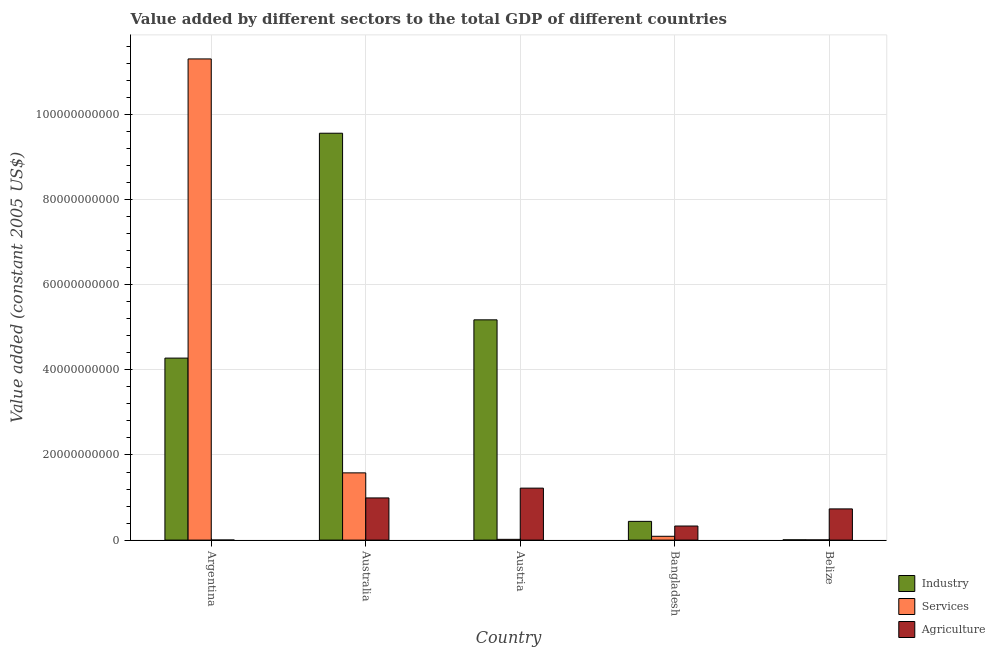How many different coloured bars are there?
Your response must be concise. 3. Are the number of bars per tick equal to the number of legend labels?
Offer a terse response. Yes. Are the number of bars on each tick of the X-axis equal?
Your answer should be compact. Yes. What is the value added by services in Austria?
Your response must be concise. 1.81e+08. Across all countries, what is the maximum value added by services?
Offer a very short reply. 1.13e+11. Across all countries, what is the minimum value added by industrial sector?
Offer a very short reply. 6.39e+07. In which country was the value added by services maximum?
Keep it short and to the point. Argentina. In which country was the value added by services minimum?
Give a very brief answer. Belize. What is the total value added by agricultural sector in the graph?
Ensure brevity in your answer.  3.28e+1. What is the difference between the value added by agricultural sector in Argentina and that in Austria?
Your answer should be compact. -1.22e+1. What is the difference between the value added by agricultural sector in Belize and the value added by industrial sector in Austria?
Your answer should be very brief. -4.44e+1. What is the average value added by services per country?
Keep it short and to the point. 2.60e+1. What is the difference between the value added by industrial sector and value added by services in Argentina?
Your answer should be very brief. -7.03e+1. What is the ratio of the value added by services in Austria to that in Bangladesh?
Ensure brevity in your answer.  0.2. Is the value added by agricultural sector in Argentina less than that in Bangladesh?
Your response must be concise. Yes. What is the difference between the highest and the second highest value added by industrial sector?
Offer a very short reply. 4.39e+1. What is the difference between the highest and the lowest value added by services?
Provide a succinct answer. 1.13e+11. Is the sum of the value added by industrial sector in Australia and Belize greater than the maximum value added by agricultural sector across all countries?
Provide a succinct answer. Yes. What does the 1st bar from the left in Argentina represents?
Offer a terse response. Industry. What does the 3rd bar from the right in Argentina represents?
Your response must be concise. Industry. Are all the bars in the graph horizontal?
Offer a terse response. No. What is the difference between two consecutive major ticks on the Y-axis?
Provide a succinct answer. 2.00e+1. Are the values on the major ticks of Y-axis written in scientific E-notation?
Keep it short and to the point. No. Does the graph contain any zero values?
Ensure brevity in your answer.  No. Does the graph contain grids?
Keep it short and to the point. Yes. How are the legend labels stacked?
Your answer should be compact. Vertical. What is the title of the graph?
Your answer should be compact. Value added by different sectors to the total GDP of different countries. What is the label or title of the X-axis?
Your answer should be compact. Country. What is the label or title of the Y-axis?
Your response must be concise. Value added (constant 2005 US$). What is the Value added (constant 2005 US$) in Industry in Argentina?
Ensure brevity in your answer.  4.28e+1. What is the Value added (constant 2005 US$) of Services in Argentina?
Provide a succinct answer. 1.13e+11. What is the Value added (constant 2005 US$) in Agriculture in Argentina?
Offer a terse response. 1.01e+07. What is the Value added (constant 2005 US$) of Industry in Australia?
Your response must be concise. 9.56e+1. What is the Value added (constant 2005 US$) in Services in Australia?
Your answer should be compact. 1.58e+1. What is the Value added (constant 2005 US$) in Agriculture in Australia?
Offer a terse response. 9.91e+09. What is the Value added (constant 2005 US$) in Industry in Austria?
Give a very brief answer. 5.18e+1. What is the Value added (constant 2005 US$) of Services in Austria?
Keep it short and to the point. 1.81e+08. What is the Value added (constant 2005 US$) of Agriculture in Austria?
Ensure brevity in your answer.  1.22e+1. What is the Value added (constant 2005 US$) in Industry in Bangladesh?
Your answer should be compact. 4.40e+09. What is the Value added (constant 2005 US$) in Services in Bangladesh?
Provide a short and direct response. 8.97e+08. What is the Value added (constant 2005 US$) of Agriculture in Bangladesh?
Keep it short and to the point. 3.31e+09. What is the Value added (constant 2005 US$) in Industry in Belize?
Ensure brevity in your answer.  6.39e+07. What is the Value added (constant 2005 US$) of Services in Belize?
Offer a very short reply. 4.88e+07. What is the Value added (constant 2005 US$) of Agriculture in Belize?
Keep it short and to the point. 7.33e+09. Across all countries, what is the maximum Value added (constant 2005 US$) of Industry?
Provide a short and direct response. 9.56e+1. Across all countries, what is the maximum Value added (constant 2005 US$) in Services?
Make the answer very short. 1.13e+11. Across all countries, what is the maximum Value added (constant 2005 US$) of Agriculture?
Your answer should be very brief. 1.22e+1. Across all countries, what is the minimum Value added (constant 2005 US$) in Industry?
Your answer should be compact. 6.39e+07. Across all countries, what is the minimum Value added (constant 2005 US$) in Services?
Make the answer very short. 4.88e+07. Across all countries, what is the minimum Value added (constant 2005 US$) of Agriculture?
Your answer should be very brief. 1.01e+07. What is the total Value added (constant 2005 US$) in Industry in the graph?
Your response must be concise. 1.95e+11. What is the total Value added (constant 2005 US$) in Services in the graph?
Provide a succinct answer. 1.30e+11. What is the total Value added (constant 2005 US$) in Agriculture in the graph?
Your answer should be compact. 3.28e+1. What is the difference between the Value added (constant 2005 US$) in Industry in Argentina and that in Australia?
Provide a succinct answer. -5.28e+1. What is the difference between the Value added (constant 2005 US$) in Services in Argentina and that in Australia?
Keep it short and to the point. 9.73e+1. What is the difference between the Value added (constant 2005 US$) in Agriculture in Argentina and that in Australia?
Make the answer very short. -9.90e+09. What is the difference between the Value added (constant 2005 US$) in Industry in Argentina and that in Austria?
Make the answer very short. -8.99e+09. What is the difference between the Value added (constant 2005 US$) of Services in Argentina and that in Austria?
Offer a very short reply. 1.13e+11. What is the difference between the Value added (constant 2005 US$) in Agriculture in Argentina and that in Austria?
Your answer should be compact. -1.22e+1. What is the difference between the Value added (constant 2005 US$) of Industry in Argentina and that in Bangladesh?
Offer a very short reply. 3.84e+1. What is the difference between the Value added (constant 2005 US$) of Services in Argentina and that in Bangladesh?
Ensure brevity in your answer.  1.12e+11. What is the difference between the Value added (constant 2005 US$) in Agriculture in Argentina and that in Bangladesh?
Provide a short and direct response. -3.30e+09. What is the difference between the Value added (constant 2005 US$) in Industry in Argentina and that in Belize?
Your answer should be very brief. 4.27e+1. What is the difference between the Value added (constant 2005 US$) of Services in Argentina and that in Belize?
Keep it short and to the point. 1.13e+11. What is the difference between the Value added (constant 2005 US$) of Agriculture in Argentina and that in Belize?
Ensure brevity in your answer.  -7.32e+09. What is the difference between the Value added (constant 2005 US$) in Industry in Australia and that in Austria?
Provide a short and direct response. 4.39e+1. What is the difference between the Value added (constant 2005 US$) of Services in Australia and that in Austria?
Ensure brevity in your answer.  1.56e+1. What is the difference between the Value added (constant 2005 US$) in Agriculture in Australia and that in Austria?
Your answer should be compact. -2.30e+09. What is the difference between the Value added (constant 2005 US$) of Industry in Australia and that in Bangladesh?
Provide a short and direct response. 9.12e+1. What is the difference between the Value added (constant 2005 US$) of Services in Australia and that in Bangladesh?
Make the answer very short. 1.49e+1. What is the difference between the Value added (constant 2005 US$) of Agriculture in Australia and that in Bangladesh?
Offer a very short reply. 6.60e+09. What is the difference between the Value added (constant 2005 US$) in Industry in Australia and that in Belize?
Offer a very short reply. 9.55e+1. What is the difference between the Value added (constant 2005 US$) in Services in Australia and that in Belize?
Offer a very short reply. 1.58e+1. What is the difference between the Value added (constant 2005 US$) of Agriculture in Australia and that in Belize?
Your response must be concise. 2.58e+09. What is the difference between the Value added (constant 2005 US$) in Industry in Austria and that in Bangladesh?
Your answer should be compact. 4.74e+1. What is the difference between the Value added (constant 2005 US$) of Services in Austria and that in Bangladesh?
Provide a succinct answer. -7.16e+08. What is the difference between the Value added (constant 2005 US$) in Agriculture in Austria and that in Bangladesh?
Your response must be concise. 8.90e+09. What is the difference between the Value added (constant 2005 US$) of Industry in Austria and that in Belize?
Provide a succinct answer. 5.17e+1. What is the difference between the Value added (constant 2005 US$) of Services in Austria and that in Belize?
Your answer should be compact. 1.32e+08. What is the difference between the Value added (constant 2005 US$) of Agriculture in Austria and that in Belize?
Your response must be concise. 4.88e+09. What is the difference between the Value added (constant 2005 US$) of Industry in Bangladesh and that in Belize?
Your response must be concise. 4.34e+09. What is the difference between the Value added (constant 2005 US$) of Services in Bangladesh and that in Belize?
Make the answer very short. 8.48e+08. What is the difference between the Value added (constant 2005 US$) in Agriculture in Bangladesh and that in Belize?
Provide a succinct answer. -4.02e+09. What is the difference between the Value added (constant 2005 US$) of Industry in Argentina and the Value added (constant 2005 US$) of Services in Australia?
Keep it short and to the point. 2.70e+1. What is the difference between the Value added (constant 2005 US$) of Industry in Argentina and the Value added (constant 2005 US$) of Agriculture in Australia?
Ensure brevity in your answer.  3.29e+1. What is the difference between the Value added (constant 2005 US$) in Services in Argentina and the Value added (constant 2005 US$) in Agriculture in Australia?
Make the answer very short. 1.03e+11. What is the difference between the Value added (constant 2005 US$) in Industry in Argentina and the Value added (constant 2005 US$) in Services in Austria?
Offer a terse response. 4.26e+1. What is the difference between the Value added (constant 2005 US$) of Industry in Argentina and the Value added (constant 2005 US$) of Agriculture in Austria?
Give a very brief answer. 3.06e+1. What is the difference between the Value added (constant 2005 US$) in Services in Argentina and the Value added (constant 2005 US$) in Agriculture in Austria?
Your answer should be very brief. 1.01e+11. What is the difference between the Value added (constant 2005 US$) in Industry in Argentina and the Value added (constant 2005 US$) in Services in Bangladesh?
Provide a succinct answer. 4.19e+1. What is the difference between the Value added (constant 2005 US$) in Industry in Argentina and the Value added (constant 2005 US$) in Agriculture in Bangladesh?
Offer a very short reply. 3.95e+1. What is the difference between the Value added (constant 2005 US$) in Services in Argentina and the Value added (constant 2005 US$) in Agriculture in Bangladesh?
Offer a very short reply. 1.10e+11. What is the difference between the Value added (constant 2005 US$) of Industry in Argentina and the Value added (constant 2005 US$) of Services in Belize?
Provide a short and direct response. 4.27e+1. What is the difference between the Value added (constant 2005 US$) of Industry in Argentina and the Value added (constant 2005 US$) of Agriculture in Belize?
Your response must be concise. 3.54e+1. What is the difference between the Value added (constant 2005 US$) of Services in Argentina and the Value added (constant 2005 US$) of Agriculture in Belize?
Ensure brevity in your answer.  1.06e+11. What is the difference between the Value added (constant 2005 US$) in Industry in Australia and the Value added (constant 2005 US$) in Services in Austria?
Your response must be concise. 9.54e+1. What is the difference between the Value added (constant 2005 US$) in Industry in Australia and the Value added (constant 2005 US$) in Agriculture in Austria?
Make the answer very short. 8.34e+1. What is the difference between the Value added (constant 2005 US$) in Services in Australia and the Value added (constant 2005 US$) in Agriculture in Austria?
Your response must be concise. 3.59e+09. What is the difference between the Value added (constant 2005 US$) in Industry in Australia and the Value added (constant 2005 US$) in Services in Bangladesh?
Keep it short and to the point. 9.47e+1. What is the difference between the Value added (constant 2005 US$) of Industry in Australia and the Value added (constant 2005 US$) of Agriculture in Bangladesh?
Offer a terse response. 9.23e+1. What is the difference between the Value added (constant 2005 US$) in Services in Australia and the Value added (constant 2005 US$) in Agriculture in Bangladesh?
Offer a terse response. 1.25e+1. What is the difference between the Value added (constant 2005 US$) in Industry in Australia and the Value added (constant 2005 US$) in Services in Belize?
Keep it short and to the point. 9.56e+1. What is the difference between the Value added (constant 2005 US$) in Industry in Australia and the Value added (constant 2005 US$) in Agriculture in Belize?
Provide a succinct answer. 8.83e+1. What is the difference between the Value added (constant 2005 US$) in Services in Australia and the Value added (constant 2005 US$) in Agriculture in Belize?
Your response must be concise. 8.47e+09. What is the difference between the Value added (constant 2005 US$) in Industry in Austria and the Value added (constant 2005 US$) in Services in Bangladesh?
Offer a terse response. 5.09e+1. What is the difference between the Value added (constant 2005 US$) in Industry in Austria and the Value added (constant 2005 US$) in Agriculture in Bangladesh?
Your answer should be compact. 4.85e+1. What is the difference between the Value added (constant 2005 US$) in Services in Austria and the Value added (constant 2005 US$) in Agriculture in Bangladesh?
Offer a terse response. -3.13e+09. What is the difference between the Value added (constant 2005 US$) of Industry in Austria and the Value added (constant 2005 US$) of Services in Belize?
Make the answer very short. 5.17e+1. What is the difference between the Value added (constant 2005 US$) in Industry in Austria and the Value added (constant 2005 US$) in Agriculture in Belize?
Keep it short and to the point. 4.44e+1. What is the difference between the Value added (constant 2005 US$) of Services in Austria and the Value added (constant 2005 US$) of Agriculture in Belize?
Provide a short and direct response. -7.15e+09. What is the difference between the Value added (constant 2005 US$) of Industry in Bangladesh and the Value added (constant 2005 US$) of Services in Belize?
Your answer should be compact. 4.35e+09. What is the difference between the Value added (constant 2005 US$) of Industry in Bangladesh and the Value added (constant 2005 US$) of Agriculture in Belize?
Make the answer very short. -2.93e+09. What is the difference between the Value added (constant 2005 US$) in Services in Bangladesh and the Value added (constant 2005 US$) in Agriculture in Belize?
Provide a succinct answer. -6.43e+09. What is the average Value added (constant 2005 US$) in Industry per country?
Make the answer very short. 3.89e+1. What is the average Value added (constant 2005 US$) in Services per country?
Keep it short and to the point. 2.60e+1. What is the average Value added (constant 2005 US$) in Agriculture per country?
Provide a succinct answer. 6.55e+09. What is the difference between the Value added (constant 2005 US$) of Industry and Value added (constant 2005 US$) of Services in Argentina?
Your answer should be compact. -7.03e+1. What is the difference between the Value added (constant 2005 US$) of Industry and Value added (constant 2005 US$) of Agriculture in Argentina?
Your answer should be compact. 4.28e+1. What is the difference between the Value added (constant 2005 US$) in Services and Value added (constant 2005 US$) in Agriculture in Argentina?
Offer a very short reply. 1.13e+11. What is the difference between the Value added (constant 2005 US$) in Industry and Value added (constant 2005 US$) in Services in Australia?
Your response must be concise. 7.98e+1. What is the difference between the Value added (constant 2005 US$) of Industry and Value added (constant 2005 US$) of Agriculture in Australia?
Provide a short and direct response. 8.57e+1. What is the difference between the Value added (constant 2005 US$) in Services and Value added (constant 2005 US$) in Agriculture in Australia?
Make the answer very short. 5.89e+09. What is the difference between the Value added (constant 2005 US$) of Industry and Value added (constant 2005 US$) of Services in Austria?
Your answer should be very brief. 5.16e+1. What is the difference between the Value added (constant 2005 US$) of Industry and Value added (constant 2005 US$) of Agriculture in Austria?
Provide a short and direct response. 3.95e+1. What is the difference between the Value added (constant 2005 US$) in Services and Value added (constant 2005 US$) in Agriculture in Austria?
Keep it short and to the point. -1.20e+1. What is the difference between the Value added (constant 2005 US$) in Industry and Value added (constant 2005 US$) in Services in Bangladesh?
Keep it short and to the point. 3.50e+09. What is the difference between the Value added (constant 2005 US$) of Industry and Value added (constant 2005 US$) of Agriculture in Bangladesh?
Offer a very short reply. 1.09e+09. What is the difference between the Value added (constant 2005 US$) in Services and Value added (constant 2005 US$) in Agriculture in Bangladesh?
Provide a succinct answer. -2.41e+09. What is the difference between the Value added (constant 2005 US$) of Industry and Value added (constant 2005 US$) of Services in Belize?
Provide a succinct answer. 1.51e+07. What is the difference between the Value added (constant 2005 US$) of Industry and Value added (constant 2005 US$) of Agriculture in Belize?
Provide a short and direct response. -7.27e+09. What is the difference between the Value added (constant 2005 US$) in Services and Value added (constant 2005 US$) in Agriculture in Belize?
Your answer should be compact. -7.28e+09. What is the ratio of the Value added (constant 2005 US$) in Industry in Argentina to that in Australia?
Offer a terse response. 0.45. What is the ratio of the Value added (constant 2005 US$) of Services in Argentina to that in Australia?
Your answer should be very brief. 7.16. What is the ratio of the Value added (constant 2005 US$) of Agriculture in Argentina to that in Australia?
Offer a very short reply. 0. What is the ratio of the Value added (constant 2005 US$) of Industry in Argentina to that in Austria?
Keep it short and to the point. 0.83. What is the ratio of the Value added (constant 2005 US$) in Services in Argentina to that in Austria?
Your answer should be very brief. 624.82. What is the ratio of the Value added (constant 2005 US$) of Agriculture in Argentina to that in Austria?
Ensure brevity in your answer.  0. What is the ratio of the Value added (constant 2005 US$) in Industry in Argentina to that in Bangladesh?
Your response must be concise. 9.72. What is the ratio of the Value added (constant 2005 US$) of Services in Argentina to that in Bangladesh?
Your answer should be compact. 126.03. What is the ratio of the Value added (constant 2005 US$) of Agriculture in Argentina to that in Bangladesh?
Make the answer very short. 0. What is the ratio of the Value added (constant 2005 US$) of Industry in Argentina to that in Belize?
Your answer should be very brief. 669.31. What is the ratio of the Value added (constant 2005 US$) in Services in Argentina to that in Belize?
Ensure brevity in your answer.  2317.58. What is the ratio of the Value added (constant 2005 US$) in Agriculture in Argentina to that in Belize?
Keep it short and to the point. 0. What is the ratio of the Value added (constant 2005 US$) in Industry in Australia to that in Austria?
Offer a very short reply. 1.85. What is the ratio of the Value added (constant 2005 US$) of Services in Australia to that in Austria?
Ensure brevity in your answer.  87.31. What is the ratio of the Value added (constant 2005 US$) in Agriculture in Australia to that in Austria?
Offer a terse response. 0.81. What is the ratio of the Value added (constant 2005 US$) in Industry in Australia to that in Bangladesh?
Provide a short and direct response. 21.73. What is the ratio of the Value added (constant 2005 US$) of Services in Australia to that in Bangladesh?
Provide a short and direct response. 17.61. What is the ratio of the Value added (constant 2005 US$) of Agriculture in Australia to that in Bangladesh?
Offer a very short reply. 3. What is the ratio of the Value added (constant 2005 US$) in Industry in Australia to that in Belize?
Give a very brief answer. 1496.27. What is the ratio of the Value added (constant 2005 US$) of Services in Australia to that in Belize?
Your response must be concise. 323.87. What is the ratio of the Value added (constant 2005 US$) in Agriculture in Australia to that in Belize?
Provide a succinct answer. 1.35. What is the ratio of the Value added (constant 2005 US$) of Industry in Austria to that in Bangladesh?
Provide a short and direct response. 11.76. What is the ratio of the Value added (constant 2005 US$) of Services in Austria to that in Bangladesh?
Provide a succinct answer. 0.2. What is the ratio of the Value added (constant 2005 US$) of Agriculture in Austria to that in Bangladesh?
Give a very brief answer. 3.69. What is the ratio of the Value added (constant 2005 US$) in Industry in Austria to that in Belize?
Give a very brief answer. 810.01. What is the ratio of the Value added (constant 2005 US$) in Services in Austria to that in Belize?
Keep it short and to the point. 3.71. What is the ratio of the Value added (constant 2005 US$) in Agriculture in Austria to that in Belize?
Provide a succinct answer. 1.67. What is the ratio of the Value added (constant 2005 US$) in Industry in Bangladesh to that in Belize?
Give a very brief answer. 68.87. What is the ratio of the Value added (constant 2005 US$) in Services in Bangladesh to that in Belize?
Offer a terse response. 18.39. What is the ratio of the Value added (constant 2005 US$) in Agriculture in Bangladesh to that in Belize?
Provide a succinct answer. 0.45. What is the difference between the highest and the second highest Value added (constant 2005 US$) in Industry?
Offer a terse response. 4.39e+1. What is the difference between the highest and the second highest Value added (constant 2005 US$) of Services?
Keep it short and to the point. 9.73e+1. What is the difference between the highest and the second highest Value added (constant 2005 US$) in Agriculture?
Keep it short and to the point. 2.30e+09. What is the difference between the highest and the lowest Value added (constant 2005 US$) of Industry?
Provide a succinct answer. 9.55e+1. What is the difference between the highest and the lowest Value added (constant 2005 US$) of Services?
Keep it short and to the point. 1.13e+11. What is the difference between the highest and the lowest Value added (constant 2005 US$) of Agriculture?
Keep it short and to the point. 1.22e+1. 